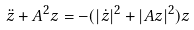<formula> <loc_0><loc_0><loc_500><loc_500>\ddot { z } + A ^ { 2 } z = - ( | \dot { z } | ^ { 2 } + | A z | ^ { 2 } ) z</formula> 